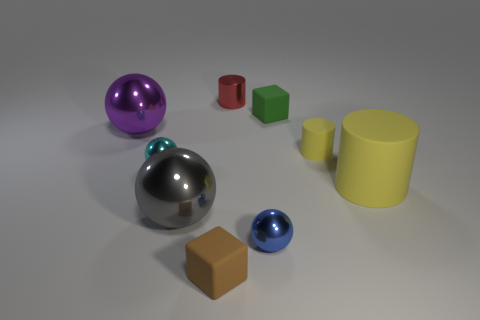There is a thing that is the same color as the big matte cylinder; what size is it?
Your answer should be very brief. Small. Are there any cyan balls in front of the tiny matte block that is left of the tiny metallic cylinder?
Offer a terse response. No. Is the number of big metal objects on the right side of the gray object less than the number of tiny green objects in front of the cyan ball?
Your answer should be compact. No. There is a purple thing; what shape is it?
Provide a short and direct response. Sphere. There is a cylinder that is in front of the small cyan metallic ball; what is its material?
Provide a short and direct response. Rubber. There is a gray metal thing behind the small matte block in front of the shiny sphere that is right of the gray metal object; what is its size?
Your response must be concise. Large. Is the small cylinder that is right of the red metal cylinder made of the same material as the cylinder left of the green matte thing?
Provide a succinct answer. No. How many other things are the same color as the small shiny cylinder?
Your response must be concise. 0. How many things are spheres that are on the right side of the gray shiny sphere or cubes that are left of the red metal object?
Provide a succinct answer. 2. There is a yellow rubber thing in front of the tiny cylinder in front of the small red cylinder; what is its size?
Provide a short and direct response. Large. 